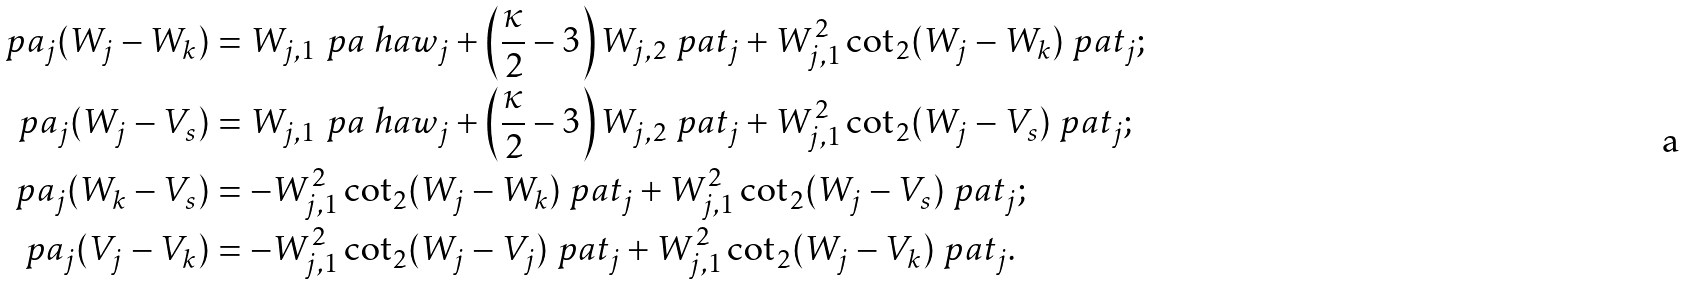Convert formula to latex. <formula><loc_0><loc_0><loc_500><loc_500>\ p a _ { j } ( W _ { j } - W _ { k } ) & = W _ { j , 1 } \ p a \ h a w _ { j } + \left ( \frac { \kappa } { 2 } - 3 \right ) W _ { j , 2 } \ p a t _ { j } + W _ { j , 1 } ^ { 2 } \cot _ { 2 } ( W _ { j } - W _ { k } ) \ p a t _ { j } ; \\ \ p a _ { j } ( W _ { j } - V _ { s } ) & = W _ { j , 1 } \ p a \ h a w _ { j } + \left ( \frac { \kappa } { 2 } - 3 \right ) W _ { j , 2 } \ p a t _ { j } + W _ { j , 1 } ^ { 2 } \cot _ { 2 } ( W _ { j } - V _ { s } ) \ p a t _ { j } ; \\ \ p a _ { j } ( W _ { k } - V _ { s } ) & = - W _ { j , 1 } ^ { 2 } \cot _ { 2 } ( W _ { j } - W _ { k } ) \ p a t _ { j } + W _ { j , 1 } ^ { 2 } \cot _ { 2 } ( W _ { j } - V _ { s } ) \ p a t _ { j } ; \\ \ p a _ { j } ( V _ { j } - V _ { k } ) & = - W _ { j , 1 } ^ { 2 } \cot _ { 2 } ( W _ { j } - V _ { j } ) \ p a t _ { j } + W _ { j , 1 } ^ { 2 } \cot _ { 2 } ( W _ { j } - V _ { k } ) \ p a t _ { j } .</formula> 